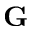<formula> <loc_0><loc_0><loc_500><loc_500>G</formula> 